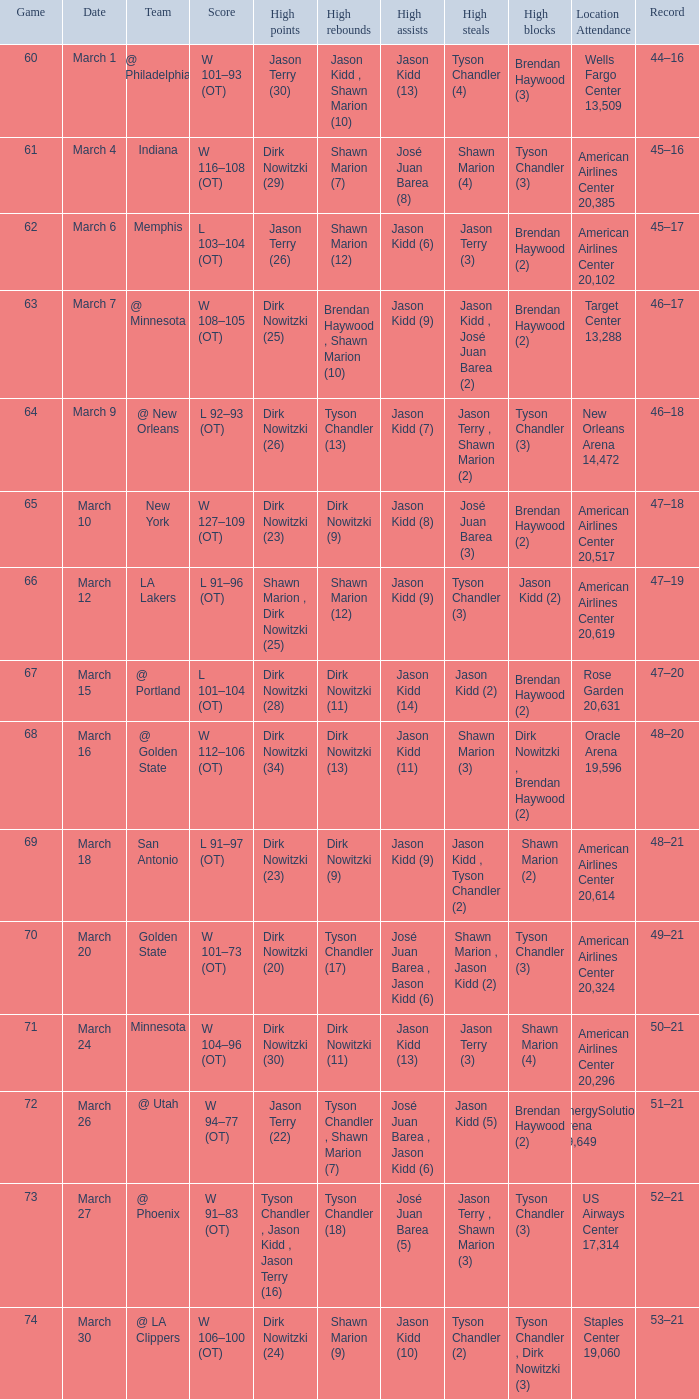Name the score for  josé juan barea (8) W 116–108 (OT). 